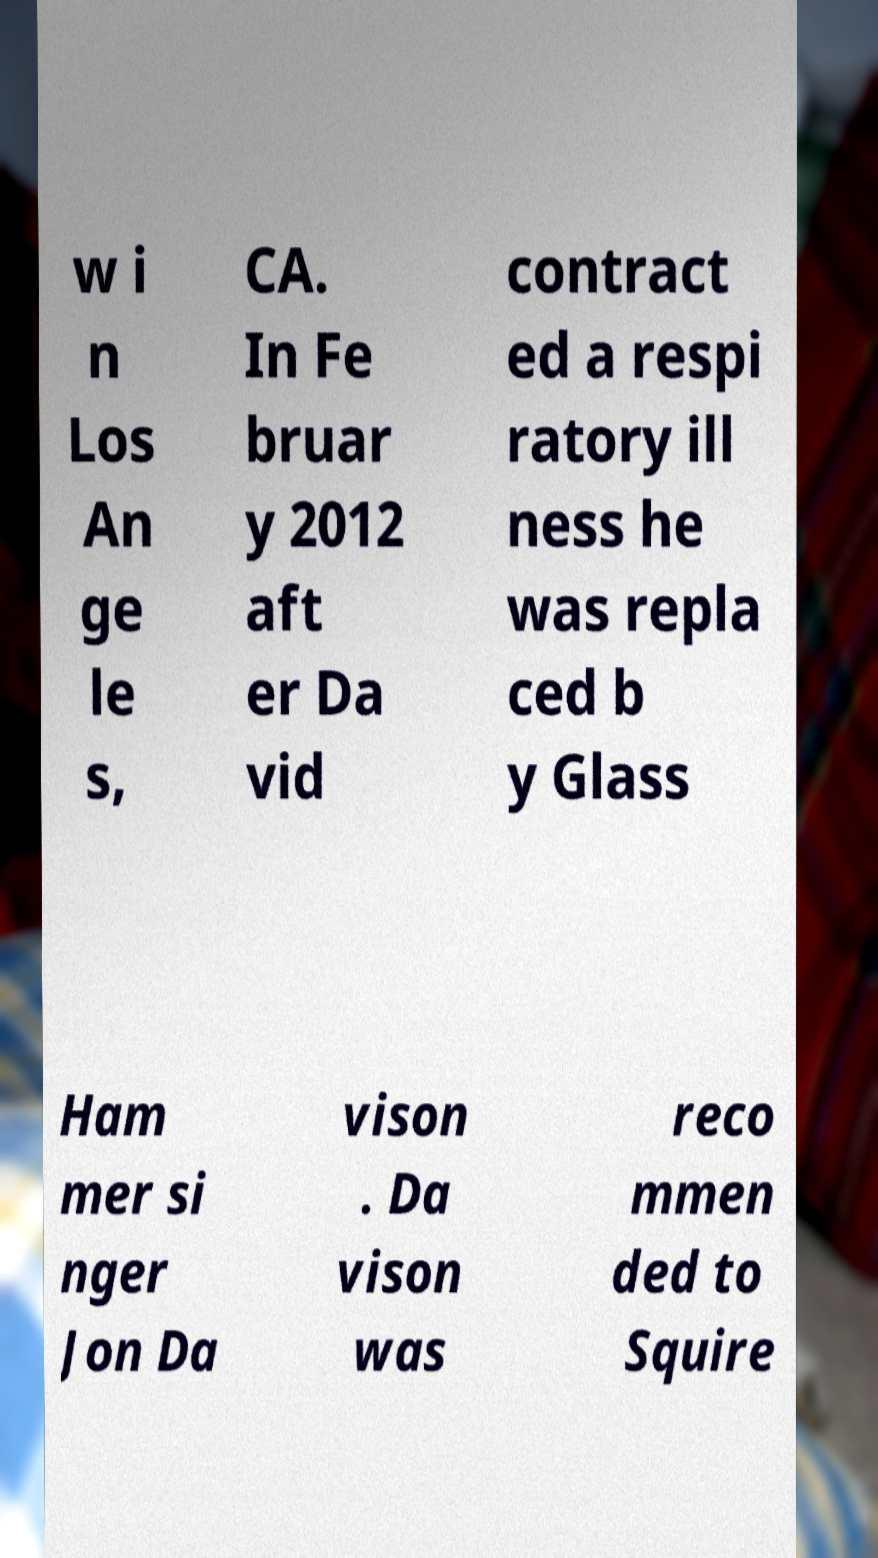Please read and relay the text visible in this image. What does it say? w i n Los An ge le s, CA. In Fe bruar y 2012 aft er Da vid contract ed a respi ratory ill ness he was repla ced b y Glass Ham mer si nger Jon Da vison . Da vison was reco mmen ded to Squire 